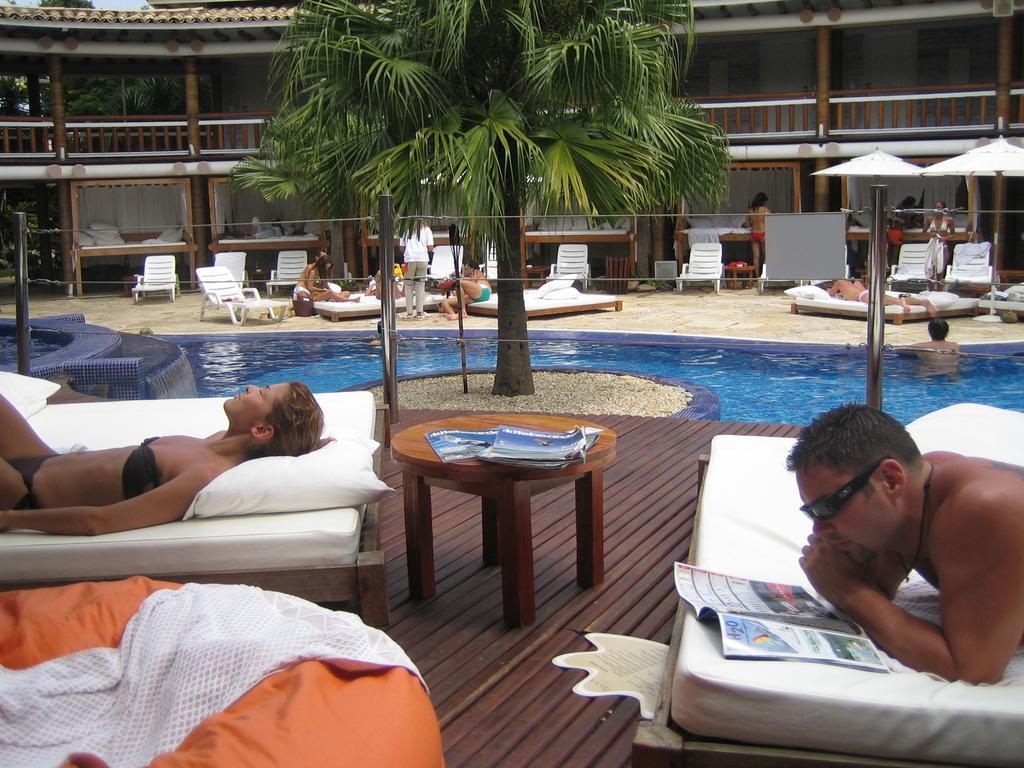Please provide a concise description of this image. There are group of people in the image who are lying on bed. On bed we can see pillows,blankets and we can also see a table in middle of the image , on table we can see two books,trees in background there is a building,pillars and sky is on top. 